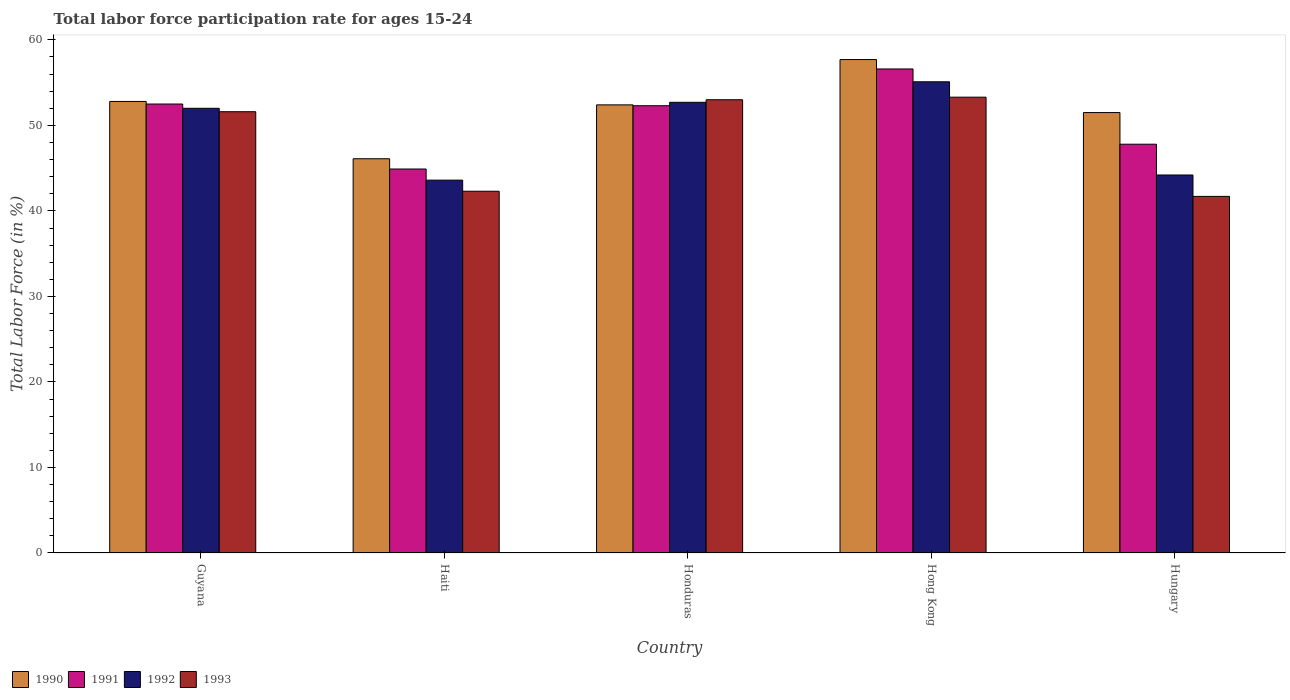How many groups of bars are there?
Offer a terse response. 5. Are the number of bars per tick equal to the number of legend labels?
Give a very brief answer. Yes. What is the label of the 3rd group of bars from the left?
Keep it short and to the point. Honduras. What is the labor force participation rate in 1992 in Haiti?
Offer a terse response. 43.6. Across all countries, what is the maximum labor force participation rate in 1992?
Provide a short and direct response. 55.1. Across all countries, what is the minimum labor force participation rate in 1993?
Your answer should be very brief. 41.7. In which country was the labor force participation rate in 1993 maximum?
Keep it short and to the point. Hong Kong. In which country was the labor force participation rate in 1993 minimum?
Your answer should be very brief. Hungary. What is the total labor force participation rate in 1992 in the graph?
Ensure brevity in your answer.  247.6. What is the difference between the labor force participation rate in 1993 in Honduras and that in Hong Kong?
Provide a short and direct response. -0.3. What is the difference between the labor force participation rate in 1991 in Hungary and the labor force participation rate in 1993 in Hong Kong?
Provide a succinct answer. -5.5. What is the average labor force participation rate in 1991 per country?
Give a very brief answer. 50.82. In how many countries, is the labor force participation rate in 1993 greater than 24 %?
Offer a terse response. 5. What is the ratio of the labor force participation rate in 1993 in Guyana to that in Hungary?
Your answer should be compact. 1.24. Is the labor force participation rate in 1991 in Guyana less than that in Haiti?
Provide a succinct answer. No. What is the difference between the highest and the second highest labor force participation rate in 1990?
Give a very brief answer. 4.9. What is the difference between the highest and the lowest labor force participation rate in 1991?
Ensure brevity in your answer.  11.7. In how many countries, is the labor force participation rate in 1991 greater than the average labor force participation rate in 1991 taken over all countries?
Your answer should be very brief. 3. Is it the case that in every country, the sum of the labor force participation rate in 1991 and labor force participation rate in 1992 is greater than the sum of labor force participation rate in 1990 and labor force participation rate in 1993?
Your answer should be very brief. No. Is it the case that in every country, the sum of the labor force participation rate in 1993 and labor force participation rate in 1990 is greater than the labor force participation rate in 1992?
Keep it short and to the point. Yes. How many bars are there?
Offer a terse response. 20. Are all the bars in the graph horizontal?
Offer a terse response. No. Does the graph contain any zero values?
Give a very brief answer. No. Where does the legend appear in the graph?
Provide a short and direct response. Bottom left. How many legend labels are there?
Provide a short and direct response. 4. How are the legend labels stacked?
Keep it short and to the point. Horizontal. What is the title of the graph?
Provide a succinct answer. Total labor force participation rate for ages 15-24. What is the label or title of the Y-axis?
Give a very brief answer. Total Labor Force (in %). What is the Total Labor Force (in %) of 1990 in Guyana?
Give a very brief answer. 52.8. What is the Total Labor Force (in %) in 1991 in Guyana?
Keep it short and to the point. 52.5. What is the Total Labor Force (in %) of 1993 in Guyana?
Keep it short and to the point. 51.6. What is the Total Labor Force (in %) in 1990 in Haiti?
Keep it short and to the point. 46.1. What is the Total Labor Force (in %) of 1991 in Haiti?
Provide a succinct answer. 44.9. What is the Total Labor Force (in %) of 1992 in Haiti?
Offer a terse response. 43.6. What is the Total Labor Force (in %) in 1993 in Haiti?
Offer a very short reply. 42.3. What is the Total Labor Force (in %) of 1990 in Honduras?
Provide a short and direct response. 52.4. What is the Total Labor Force (in %) in 1991 in Honduras?
Your response must be concise. 52.3. What is the Total Labor Force (in %) in 1992 in Honduras?
Provide a short and direct response. 52.7. What is the Total Labor Force (in %) in 1990 in Hong Kong?
Offer a terse response. 57.7. What is the Total Labor Force (in %) in 1991 in Hong Kong?
Your response must be concise. 56.6. What is the Total Labor Force (in %) in 1992 in Hong Kong?
Keep it short and to the point. 55.1. What is the Total Labor Force (in %) of 1993 in Hong Kong?
Provide a short and direct response. 53.3. What is the Total Labor Force (in %) of 1990 in Hungary?
Provide a succinct answer. 51.5. What is the Total Labor Force (in %) in 1991 in Hungary?
Provide a short and direct response. 47.8. What is the Total Labor Force (in %) of 1992 in Hungary?
Your response must be concise. 44.2. What is the Total Labor Force (in %) in 1993 in Hungary?
Your response must be concise. 41.7. Across all countries, what is the maximum Total Labor Force (in %) in 1990?
Offer a terse response. 57.7. Across all countries, what is the maximum Total Labor Force (in %) in 1991?
Provide a short and direct response. 56.6. Across all countries, what is the maximum Total Labor Force (in %) of 1992?
Provide a succinct answer. 55.1. Across all countries, what is the maximum Total Labor Force (in %) in 1993?
Offer a very short reply. 53.3. Across all countries, what is the minimum Total Labor Force (in %) of 1990?
Offer a very short reply. 46.1. Across all countries, what is the minimum Total Labor Force (in %) of 1991?
Provide a short and direct response. 44.9. Across all countries, what is the minimum Total Labor Force (in %) in 1992?
Make the answer very short. 43.6. Across all countries, what is the minimum Total Labor Force (in %) of 1993?
Give a very brief answer. 41.7. What is the total Total Labor Force (in %) of 1990 in the graph?
Offer a terse response. 260.5. What is the total Total Labor Force (in %) of 1991 in the graph?
Your response must be concise. 254.1. What is the total Total Labor Force (in %) of 1992 in the graph?
Provide a short and direct response. 247.6. What is the total Total Labor Force (in %) of 1993 in the graph?
Keep it short and to the point. 241.9. What is the difference between the Total Labor Force (in %) in 1992 in Guyana and that in Haiti?
Ensure brevity in your answer.  8.4. What is the difference between the Total Labor Force (in %) in 1990 in Guyana and that in Honduras?
Your response must be concise. 0.4. What is the difference between the Total Labor Force (in %) of 1991 in Guyana and that in Honduras?
Keep it short and to the point. 0.2. What is the difference between the Total Labor Force (in %) of 1992 in Guyana and that in Honduras?
Ensure brevity in your answer.  -0.7. What is the difference between the Total Labor Force (in %) in 1990 in Guyana and that in Hungary?
Your answer should be very brief. 1.3. What is the difference between the Total Labor Force (in %) of 1991 in Guyana and that in Hungary?
Make the answer very short. 4.7. What is the difference between the Total Labor Force (in %) of 1992 in Guyana and that in Hungary?
Your answer should be compact. 7.8. What is the difference between the Total Labor Force (in %) in 1990 in Haiti and that in Honduras?
Your answer should be very brief. -6.3. What is the difference between the Total Labor Force (in %) in 1991 in Haiti and that in Honduras?
Offer a very short reply. -7.4. What is the difference between the Total Labor Force (in %) of 1992 in Haiti and that in Honduras?
Keep it short and to the point. -9.1. What is the difference between the Total Labor Force (in %) in 1993 in Haiti and that in Honduras?
Ensure brevity in your answer.  -10.7. What is the difference between the Total Labor Force (in %) in 1990 in Haiti and that in Hong Kong?
Offer a terse response. -11.6. What is the difference between the Total Labor Force (in %) of 1992 in Haiti and that in Hong Kong?
Keep it short and to the point. -11.5. What is the difference between the Total Labor Force (in %) of 1990 in Haiti and that in Hungary?
Provide a short and direct response. -5.4. What is the difference between the Total Labor Force (in %) in 1992 in Haiti and that in Hungary?
Your response must be concise. -0.6. What is the difference between the Total Labor Force (in %) in 1990 in Honduras and that in Hong Kong?
Make the answer very short. -5.3. What is the difference between the Total Labor Force (in %) of 1992 in Honduras and that in Hong Kong?
Your answer should be compact. -2.4. What is the difference between the Total Labor Force (in %) of 1993 in Honduras and that in Hong Kong?
Ensure brevity in your answer.  -0.3. What is the difference between the Total Labor Force (in %) in 1992 in Honduras and that in Hungary?
Give a very brief answer. 8.5. What is the difference between the Total Labor Force (in %) of 1990 in Guyana and the Total Labor Force (in %) of 1991 in Haiti?
Provide a short and direct response. 7.9. What is the difference between the Total Labor Force (in %) in 1990 in Guyana and the Total Labor Force (in %) in 1993 in Haiti?
Keep it short and to the point. 10.5. What is the difference between the Total Labor Force (in %) of 1991 in Guyana and the Total Labor Force (in %) of 1993 in Haiti?
Provide a succinct answer. 10.2. What is the difference between the Total Labor Force (in %) in 1990 in Guyana and the Total Labor Force (in %) in 1991 in Honduras?
Make the answer very short. 0.5. What is the difference between the Total Labor Force (in %) in 1990 in Guyana and the Total Labor Force (in %) in 1992 in Honduras?
Provide a succinct answer. 0.1. What is the difference between the Total Labor Force (in %) of 1991 in Guyana and the Total Labor Force (in %) of 1993 in Honduras?
Your response must be concise. -0.5. What is the difference between the Total Labor Force (in %) of 1992 in Guyana and the Total Labor Force (in %) of 1993 in Honduras?
Your answer should be very brief. -1. What is the difference between the Total Labor Force (in %) in 1990 in Guyana and the Total Labor Force (in %) in 1991 in Hong Kong?
Offer a very short reply. -3.8. What is the difference between the Total Labor Force (in %) of 1991 in Guyana and the Total Labor Force (in %) of 1992 in Hong Kong?
Provide a succinct answer. -2.6. What is the difference between the Total Labor Force (in %) in 1991 in Guyana and the Total Labor Force (in %) in 1993 in Hong Kong?
Offer a very short reply. -0.8. What is the difference between the Total Labor Force (in %) in 1990 in Guyana and the Total Labor Force (in %) in 1992 in Hungary?
Offer a terse response. 8.6. What is the difference between the Total Labor Force (in %) in 1991 in Guyana and the Total Labor Force (in %) in 1992 in Hungary?
Offer a very short reply. 8.3. What is the difference between the Total Labor Force (in %) of 1992 in Guyana and the Total Labor Force (in %) of 1993 in Hungary?
Offer a very short reply. 10.3. What is the difference between the Total Labor Force (in %) of 1990 in Haiti and the Total Labor Force (in %) of 1991 in Honduras?
Provide a short and direct response. -6.2. What is the difference between the Total Labor Force (in %) in 1990 in Haiti and the Total Labor Force (in %) in 1993 in Honduras?
Offer a very short reply. -6.9. What is the difference between the Total Labor Force (in %) in 1991 in Haiti and the Total Labor Force (in %) in 1993 in Honduras?
Make the answer very short. -8.1. What is the difference between the Total Labor Force (in %) in 1990 in Haiti and the Total Labor Force (in %) in 1991 in Hong Kong?
Make the answer very short. -10.5. What is the difference between the Total Labor Force (in %) in 1990 in Haiti and the Total Labor Force (in %) in 1993 in Hong Kong?
Provide a short and direct response. -7.2. What is the difference between the Total Labor Force (in %) of 1991 in Haiti and the Total Labor Force (in %) of 1992 in Hong Kong?
Give a very brief answer. -10.2. What is the difference between the Total Labor Force (in %) in 1992 in Haiti and the Total Labor Force (in %) in 1993 in Hong Kong?
Make the answer very short. -9.7. What is the difference between the Total Labor Force (in %) in 1990 in Haiti and the Total Labor Force (in %) in 1992 in Hungary?
Give a very brief answer. 1.9. What is the difference between the Total Labor Force (in %) in 1990 in Haiti and the Total Labor Force (in %) in 1993 in Hungary?
Make the answer very short. 4.4. What is the difference between the Total Labor Force (in %) in 1991 in Haiti and the Total Labor Force (in %) in 1993 in Hungary?
Provide a succinct answer. 3.2. What is the difference between the Total Labor Force (in %) in 1990 in Honduras and the Total Labor Force (in %) in 1991 in Hong Kong?
Your answer should be very brief. -4.2. What is the difference between the Total Labor Force (in %) of 1990 in Honduras and the Total Labor Force (in %) of 1993 in Hong Kong?
Your answer should be compact. -0.9. What is the difference between the Total Labor Force (in %) in 1991 in Honduras and the Total Labor Force (in %) in 1992 in Hong Kong?
Make the answer very short. -2.8. What is the difference between the Total Labor Force (in %) in 1990 in Honduras and the Total Labor Force (in %) in 1992 in Hungary?
Your answer should be compact. 8.2. What is the difference between the Total Labor Force (in %) of 1990 in Hong Kong and the Total Labor Force (in %) of 1991 in Hungary?
Offer a very short reply. 9.9. What is the difference between the Total Labor Force (in %) of 1990 in Hong Kong and the Total Labor Force (in %) of 1993 in Hungary?
Provide a succinct answer. 16. What is the difference between the Total Labor Force (in %) in 1991 in Hong Kong and the Total Labor Force (in %) in 1992 in Hungary?
Ensure brevity in your answer.  12.4. What is the average Total Labor Force (in %) of 1990 per country?
Provide a short and direct response. 52.1. What is the average Total Labor Force (in %) of 1991 per country?
Provide a succinct answer. 50.82. What is the average Total Labor Force (in %) of 1992 per country?
Offer a terse response. 49.52. What is the average Total Labor Force (in %) of 1993 per country?
Provide a short and direct response. 48.38. What is the difference between the Total Labor Force (in %) in 1990 and Total Labor Force (in %) in 1991 in Guyana?
Your response must be concise. 0.3. What is the difference between the Total Labor Force (in %) of 1990 and Total Labor Force (in %) of 1993 in Haiti?
Provide a short and direct response. 3.8. What is the difference between the Total Labor Force (in %) of 1991 and Total Labor Force (in %) of 1992 in Haiti?
Your response must be concise. 1.3. What is the difference between the Total Labor Force (in %) in 1991 and Total Labor Force (in %) in 1993 in Haiti?
Your answer should be compact. 2.6. What is the difference between the Total Labor Force (in %) in 1990 and Total Labor Force (in %) in 1992 in Honduras?
Your answer should be compact. -0.3. What is the difference between the Total Labor Force (in %) in 1990 and Total Labor Force (in %) in 1993 in Honduras?
Provide a succinct answer. -0.6. What is the difference between the Total Labor Force (in %) of 1991 and Total Labor Force (in %) of 1993 in Honduras?
Provide a short and direct response. -0.7. What is the difference between the Total Labor Force (in %) of 1990 and Total Labor Force (in %) of 1991 in Hong Kong?
Your response must be concise. 1.1. What is the difference between the Total Labor Force (in %) in 1990 and Total Labor Force (in %) in 1992 in Hong Kong?
Your response must be concise. 2.6. What is the difference between the Total Labor Force (in %) in 1990 and Total Labor Force (in %) in 1993 in Hong Kong?
Give a very brief answer. 4.4. What is the difference between the Total Labor Force (in %) of 1990 and Total Labor Force (in %) of 1991 in Hungary?
Your answer should be compact. 3.7. What is the difference between the Total Labor Force (in %) in 1990 and Total Labor Force (in %) in 1992 in Hungary?
Your answer should be compact. 7.3. What is the difference between the Total Labor Force (in %) of 1991 and Total Labor Force (in %) of 1993 in Hungary?
Your response must be concise. 6.1. What is the ratio of the Total Labor Force (in %) in 1990 in Guyana to that in Haiti?
Ensure brevity in your answer.  1.15. What is the ratio of the Total Labor Force (in %) of 1991 in Guyana to that in Haiti?
Offer a very short reply. 1.17. What is the ratio of the Total Labor Force (in %) of 1992 in Guyana to that in Haiti?
Ensure brevity in your answer.  1.19. What is the ratio of the Total Labor Force (in %) in 1993 in Guyana to that in Haiti?
Your answer should be compact. 1.22. What is the ratio of the Total Labor Force (in %) of 1990 in Guyana to that in Honduras?
Provide a short and direct response. 1.01. What is the ratio of the Total Labor Force (in %) of 1991 in Guyana to that in Honduras?
Your answer should be compact. 1. What is the ratio of the Total Labor Force (in %) of 1992 in Guyana to that in Honduras?
Give a very brief answer. 0.99. What is the ratio of the Total Labor Force (in %) of 1993 in Guyana to that in Honduras?
Make the answer very short. 0.97. What is the ratio of the Total Labor Force (in %) of 1990 in Guyana to that in Hong Kong?
Provide a short and direct response. 0.92. What is the ratio of the Total Labor Force (in %) of 1991 in Guyana to that in Hong Kong?
Make the answer very short. 0.93. What is the ratio of the Total Labor Force (in %) of 1992 in Guyana to that in Hong Kong?
Ensure brevity in your answer.  0.94. What is the ratio of the Total Labor Force (in %) in 1993 in Guyana to that in Hong Kong?
Offer a very short reply. 0.97. What is the ratio of the Total Labor Force (in %) in 1990 in Guyana to that in Hungary?
Your response must be concise. 1.03. What is the ratio of the Total Labor Force (in %) of 1991 in Guyana to that in Hungary?
Your answer should be very brief. 1.1. What is the ratio of the Total Labor Force (in %) in 1992 in Guyana to that in Hungary?
Provide a short and direct response. 1.18. What is the ratio of the Total Labor Force (in %) in 1993 in Guyana to that in Hungary?
Provide a succinct answer. 1.24. What is the ratio of the Total Labor Force (in %) in 1990 in Haiti to that in Honduras?
Offer a terse response. 0.88. What is the ratio of the Total Labor Force (in %) of 1991 in Haiti to that in Honduras?
Make the answer very short. 0.86. What is the ratio of the Total Labor Force (in %) in 1992 in Haiti to that in Honduras?
Your answer should be very brief. 0.83. What is the ratio of the Total Labor Force (in %) in 1993 in Haiti to that in Honduras?
Your answer should be compact. 0.8. What is the ratio of the Total Labor Force (in %) in 1990 in Haiti to that in Hong Kong?
Offer a very short reply. 0.8. What is the ratio of the Total Labor Force (in %) in 1991 in Haiti to that in Hong Kong?
Provide a short and direct response. 0.79. What is the ratio of the Total Labor Force (in %) in 1992 in Haiti to that in Hong Kong?
Your response must be concise. 0.79. What is the ratio of the Total Labor Force (in %) of 1993 in Haiti to that in Hong Kong?
Your answer should be very brief. 0.79. What is the ratio of the Total Labor Force (in %) in 1990 in Haiti to that in Hungary?
Your response must be concise. 0.9. What is the ratio of the Total Labor Force (in %) in 1991 in Haiti to that in Hungary?
Provide a succinct answer. 0.94. What is the ratio of the Total Labor Force (in %) of 1992 in Haiti to that in Hungary?
Provide a succinct answer. 0.99. What is the ratio of the Total Labor Force (in %) of 1993 in Haiti to that in Hungary?
Keep it short and to the point. 1.01. What is the ratio of the Total Labor Force (in %) in 1990 in Honduras to that in Hong Kong?
Your answer should be very brief. 0.91. What is the ratio of the Total Labor Force (in %) of 1991 in Honduras to that in Hong Kong?
Your answer should be compact. 0.92. What is the ratio of the Total Labor Force (in %) of 1992 in Honduras to that in Hong Kong?
Provide a succinct answer. 0.96. What is the ratio of the Total Labor Force (in %) in 1993 in Honduras to that in Hong Kong?
Ensure brevity in your answer.  0.99. What is the ratio of the Total Labor Force (in %) of 1990 in Honduras to that in Hungary?
Offer a very short reply. 1.02. What is the ratio of the Total Labor Force (in %) of 1991 in Honduras to that in Hungary?
Your answer should be very brief. 1.09. What is the ratio of the Total Labor Force (in %) of 1992 in Honduras to that in Hungary?
Ensure brevity in your answer.  1.19. What is the ratio of the Total Labor Force (in %) in 1993 in Honduras to that in Hungary?
Give a very brief answer. 1.27. What is the ratio of the Total Labor Force (in %) in 1990 in Hong Kong to that in Hungary?
Make the answer very short. 1.12. What is the ratio of the Total Labor Force (in %) of 1991 in Hong Kong to that in Hungary?
Keep it short and to the point. 1.18. What is the ratio of the Total Labor Force (in %) in 1992 in Hong Kong to that in Hungary?
Keep it short and to the point. 1.25. What is the ratio of the Total Labor Force (in %) of 1993 in Hong Kong to that in Hungary?
Keep it short and to the point. 1.28. What is the difference between the highest and the second highest Total Labor Force (in %) of 1991?
Offer a very short reply. 4.1. What is the difference between the highest and the second highest Total Labor Force (in %) in 1993?
Keep it short and to the point. 0.3. What is the difference between the highest and the lowest Total Labor Force (in %) of 1992?
Provide a succinct answer. 11.5. 